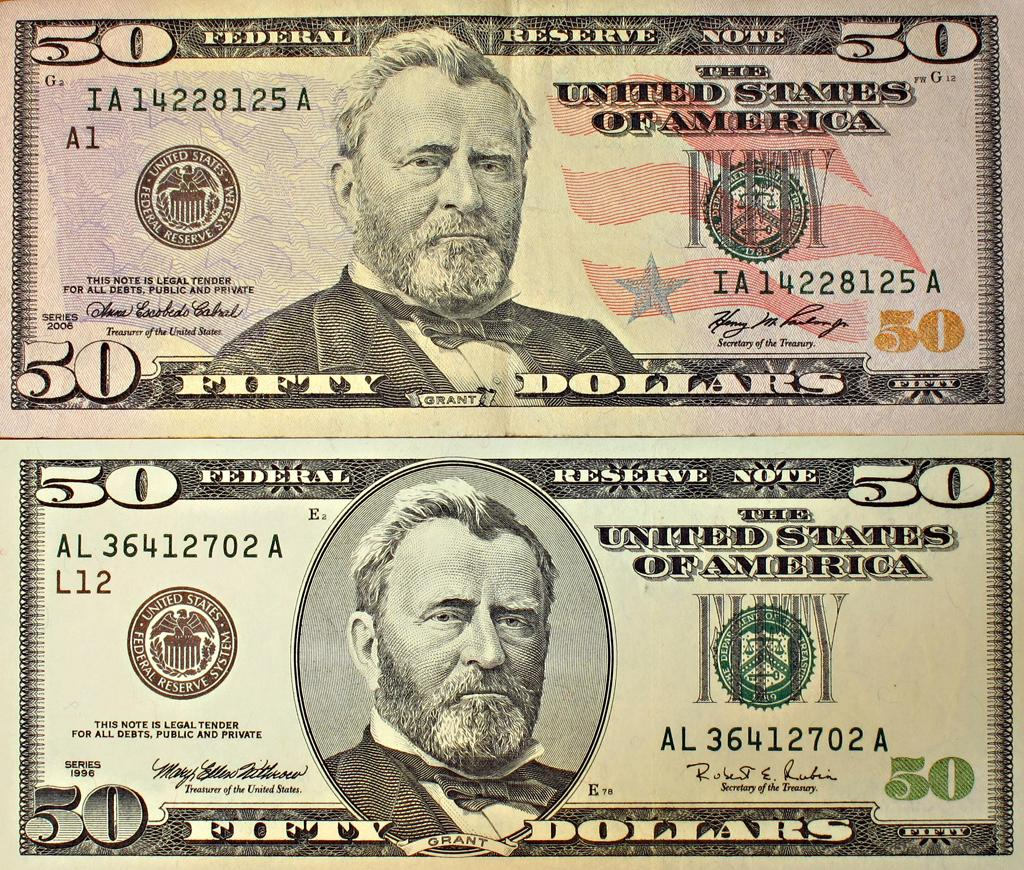What type of currency is depicted in the image? The image contains two dollar notes. Can you describe the people featured on the notes? There is a person at the bottom of each note and a person at the top of each note. What denomination are the notes? The notes are $50 notes. What type of shop can be seen in the background of the image? There is no shop present in the image; it only contains two dollar notes. Is there a crown visible on either of the notes? No, there is no crown depicted on the notes in the image. 